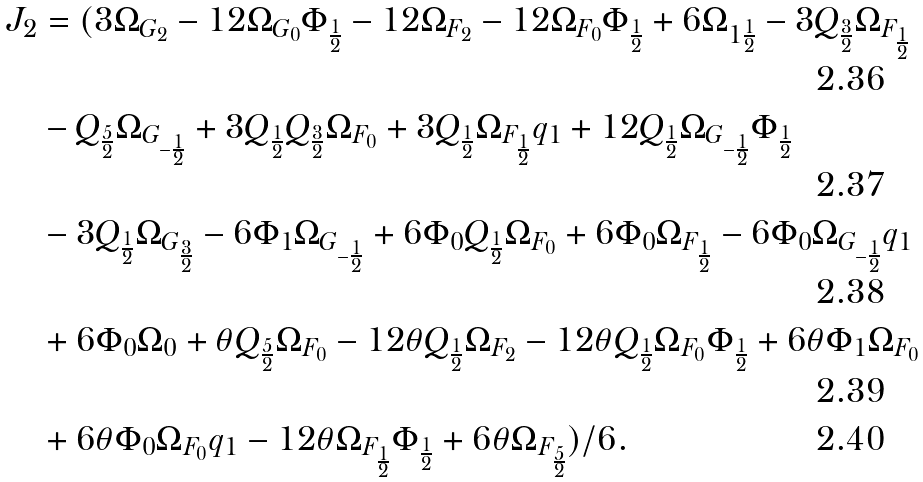Convert formula to latex. <formula><loc_0><loc_0><loc_500><loc_500>J _ { 2 } & = ( 3 \Omega _ { G _ { 2 } } - 1 2 \Omega _ { G _ { 0 } } \Phi _ { \frac { 1 } { 2 } } - 1 2 \Omega _ { F _ { 2 } } - 1 2 \Omega _ { F _ { 0 } } \Phi _ { \frac { 1 } { 2 } } + 6 \Omega _ { 1 \frac { 1 } { 2 } } - 3 Q _ { \frac { 3 } { 2 } } \Omega _ { F _ { \frac { 1 } { 2 } } } \\ & - Q _ { \frac { 5 } { 2 } } \Omega _ { G _ { - \frac { 1 } { 2 } } } + 3 Q _ { \frac { 1 } { 2 } } Q _ { \frac { 3 } { 2 } } \Omega _ { F _ { 0 } } + 3 Q _ { \frac { 1 } { 2 } } \Omega _ { F _ { \frac { 1 } { 2 } } } q _ { 1 } + 1 2 Q _ { \frac { 1 } { 2 } } \Omega _ { G _ { - \frac { 1 } { 2 } } } \Phi _ { \frac { 1 } { 2 } } \\ & - 3 Q _ { \frac { 1 } { 2 } } \Omega _ { G _ { \frac { 3 } { 2 } } } - 6 \Phi _ { 1 } \Omega _ { G _ { - \frac { 1 } { 2 } } } + 6 \Phi _ { 0 } Q _ { \frac { 1 } { 2 } } \Omega _ { F _ { 0 } } + 6 \Phi _ { 0 } \Omega _ { F _ { \frac { 1 } { 2 } } } - 6 \Phi _ { 0 } \Omega _ { G _ { - \frac { 1 } { 2 } } } q _ { 1 } \\ & + 6 \Phi _ { 0 } \Omega _ { 0 } + \theta Q _ { \frac { 5 } { 2 } } \Omega _ { F _ { 0 } } - 1 2 \theta Q _ { \frac { 1 } { 2 } } \Omega _ { F _ { 2 } } - 1 2 \theta Q _ { \frac { 1 } { 2 } } \Omega _ { F _ { 0 } } \Phi _ { \frac { 1 } { 2 } } + 6 \theta \Phi _ { 1 } \Omega _ { F _ { 0 } } \\ & + 6 \theta \Phi _ { 0 } \Omega _ { F _ { 0 } } q _ { 1 } - 1 2 \theta \Omega _ { F _ { \frac { 1 } { 2 } } } \Phi _ { \frac { 1 } { 2 } } + 6 \theta \Omega _ { F _ { \frac { 5 } { 2 } } } ) / 6 .</formula> 